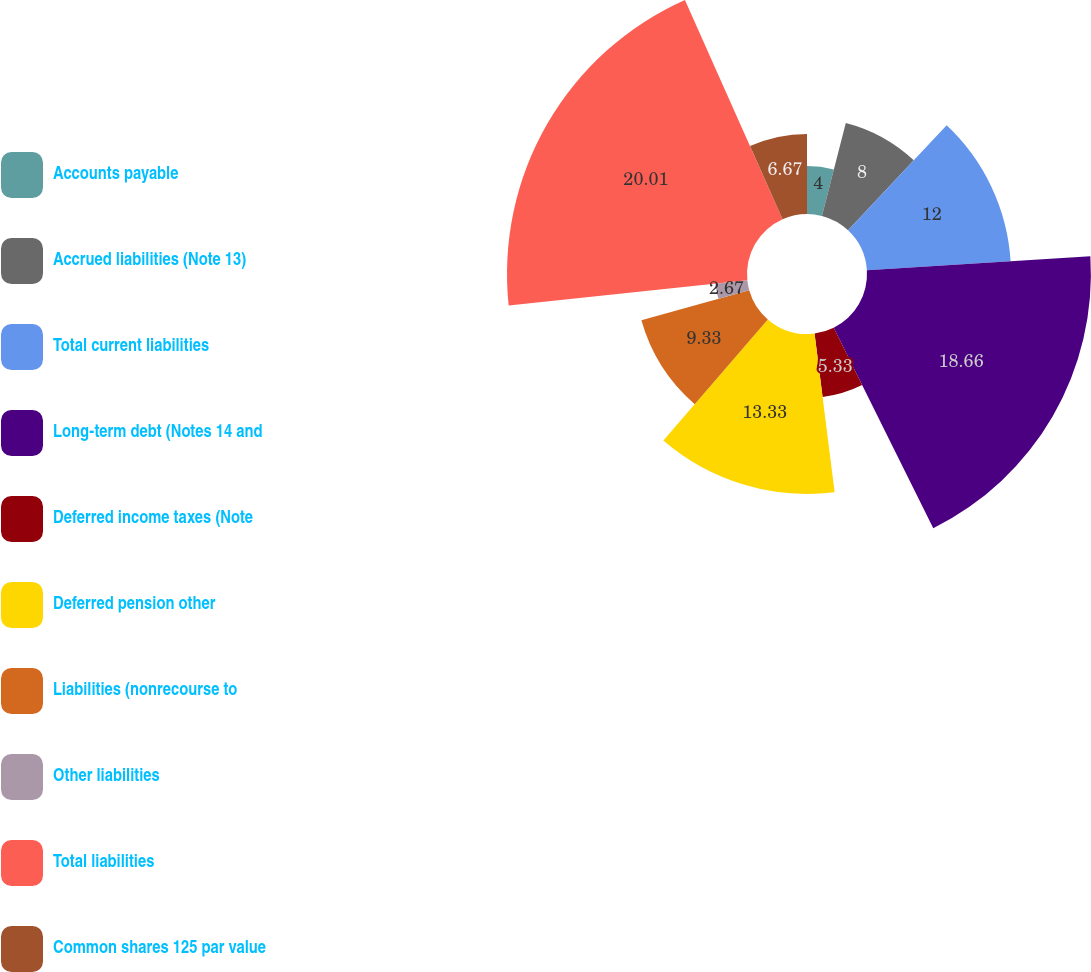Convert chart to OTSL. <chart><loc_0><loc_0><loc_500><loc_500><pie_chart><fcel>Accounts payable<fcel>Accrued liabilities (Note 13)<fcel>Total current liabilities<fcel>Long-term debt (Notes 14 and<fcel>Deferred income taxes (Note<fcel>Deferred pension other<fcel>Liabilities (nonrecourse to<fcel>Other liabilities<fcel>Total liabilities<fcel>Common shares 125 par value<nl><fcel>4.0%<fcel>8.0%<fcel>12.0%<fcel>18.66%<fcel>5.33%<fcel>13.33%<fcel>9.33%<fcel>2.67%<fcel>20.0%<fcel>6.67%<nl></chart> 